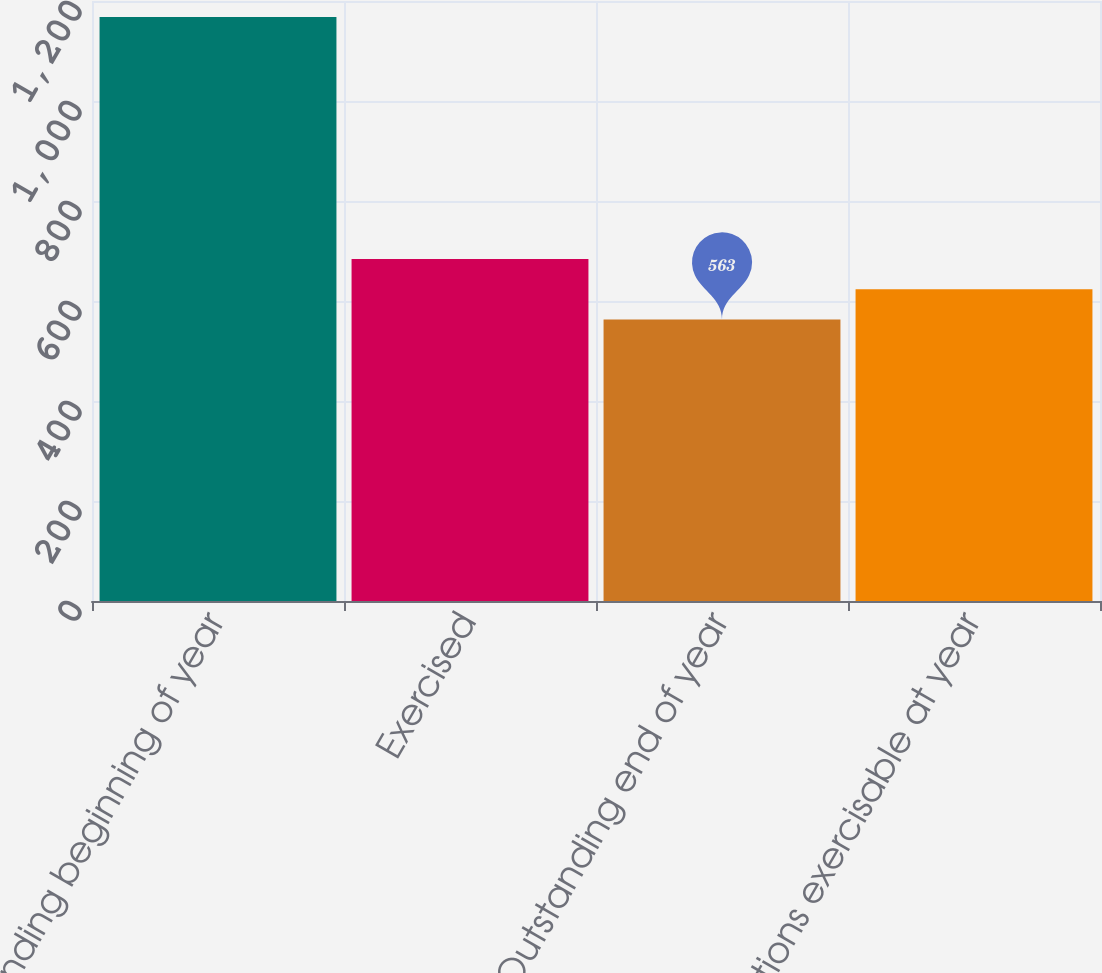Convert chart to OTSL. <chart><loc_0><loc_0><loc_500><loc_500><bar_chart><fcel>Outstanding beginning of year<fcel>Exercised<fcel>Outstanding end of year<fcel>Options exercisable at year<nl><fcel>1168<fcel>684<fcel>563<fcel>623.5<nl></chart> 